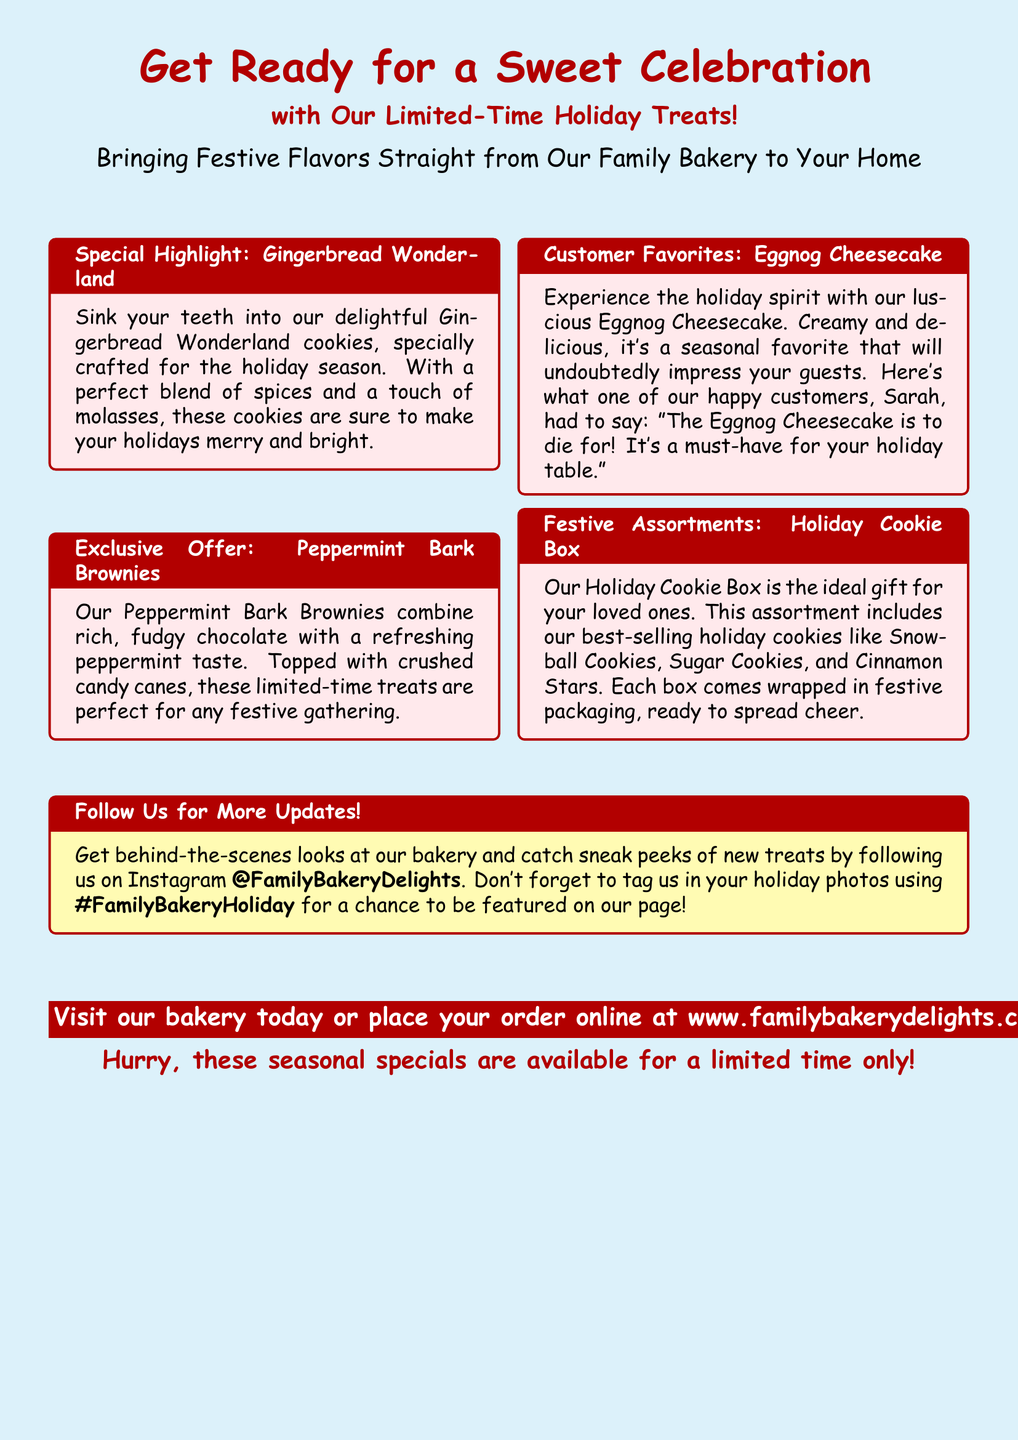What is the title of the advertisement? The title prominently displayed at the top of the advertisement indicates the main theme.
Answer: Get Ready for a Sweet Celebration What is the name of the cookie specialty featured? The advertisement highlights a specific cookie, which is part of the seasonal treats.
Answer: Gingerbread Wonderland What type of dessert is the seasonal favorite mentioned? The advertisement describes a dessert that embodies the holiday spirit and is popular among customers.
Answer: Eggnog Cheesecake What is included in the Holiday Cookie Box? The advertisement specifies the contents of a gift box offered during the holiday season.
Answer: Snowball Cookies, Sugar Cookies, Cinnamon Stars Who provided a testimonial about the Eggnog Cheesecake? The advertisement features a satisfied customer sharing their opinion on a specific dessert.
Answer: Sarah What should customers do to have a chance to be featured on social media? The advertisement encourages a certain action related to social media engagement.
Answer: Tag us in your holiday photos What flavor accompanies the Peppermint Bark Brownies? The advertisement details a key flavor component that enhances a specific treat.
Answer: Peppermint How can people order the treats mentioned? The advertisement provides information on how customers can acquire the bakery items.
Answer: Place your order online at www.familybakerydelights.com 